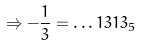<formula> <loc_0><loc_0><loc_500><loc_500>\Rightarrow - \frac { 1 } { 3 } = \dots 1 3 1 3 _ { 5 }</formula> 